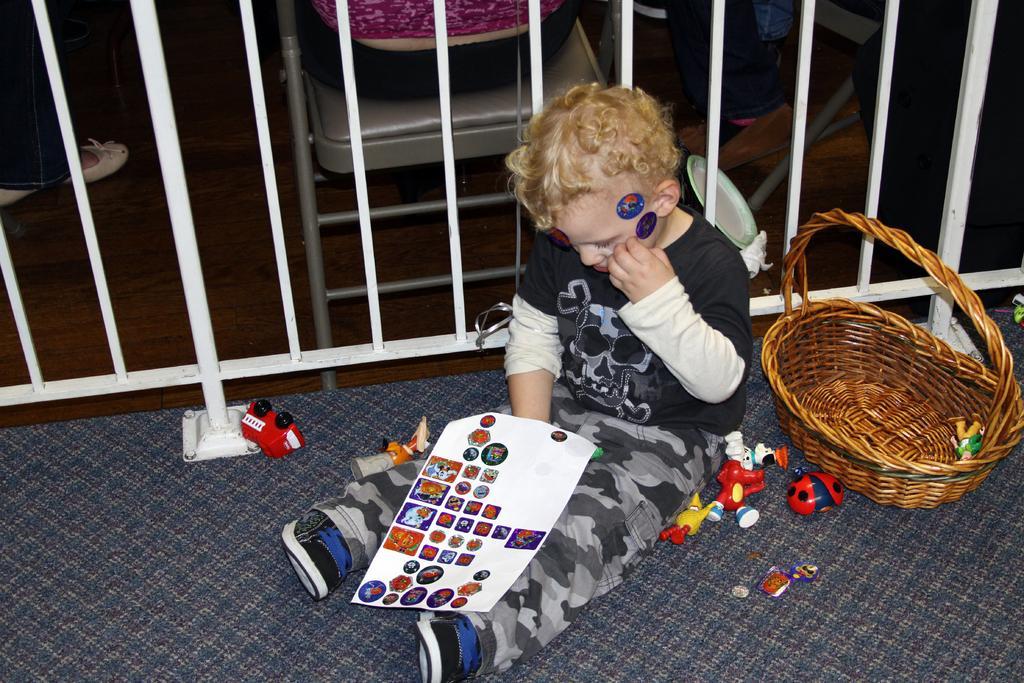How would you summarize this image in a sentence or two? In this image we can see a kid, there are stickers on his face and on the paper, there are toys on the ground, there is a toy in the basket, there is a railing, there is a person sitting on the chair, also we can see the legs of two persons. 